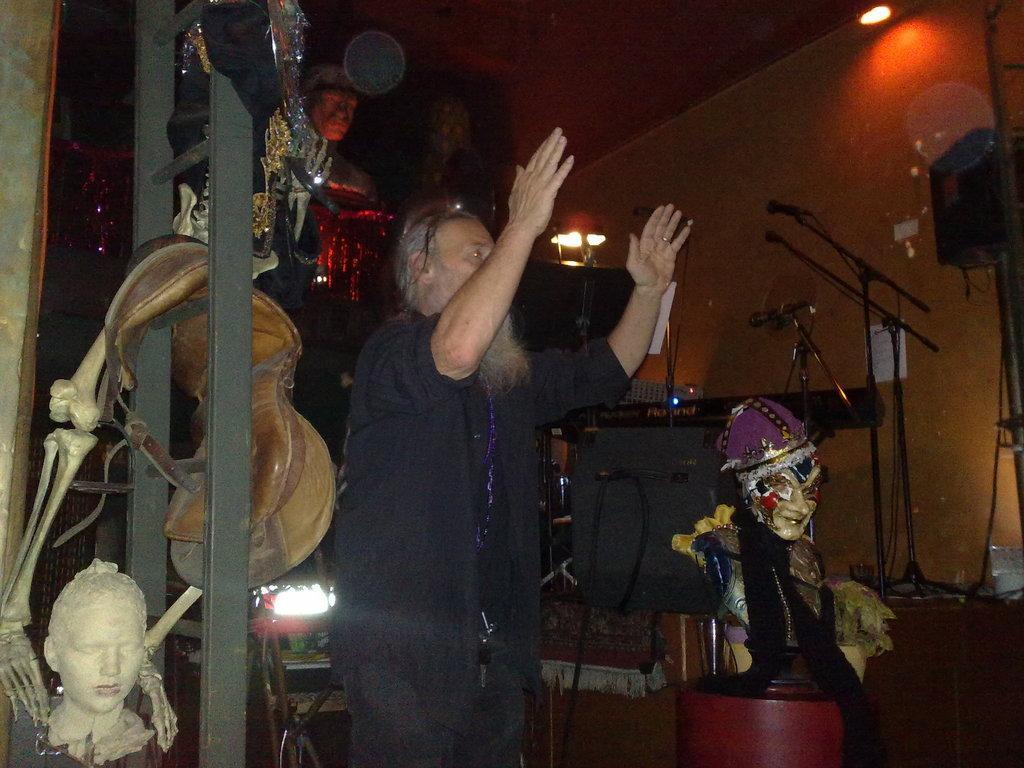Can you describe this image briefly? In this image, I can see a person standing. On the right side of the image, I can see the miles with the mike stands, speaker and few other objects. I think these are the sculptures, skeleton and few other things, which are hanging. On the left side of the image, It looks like a ladder with few things hanging on it. At the top right side of the image, that looks like a ceiling light. 